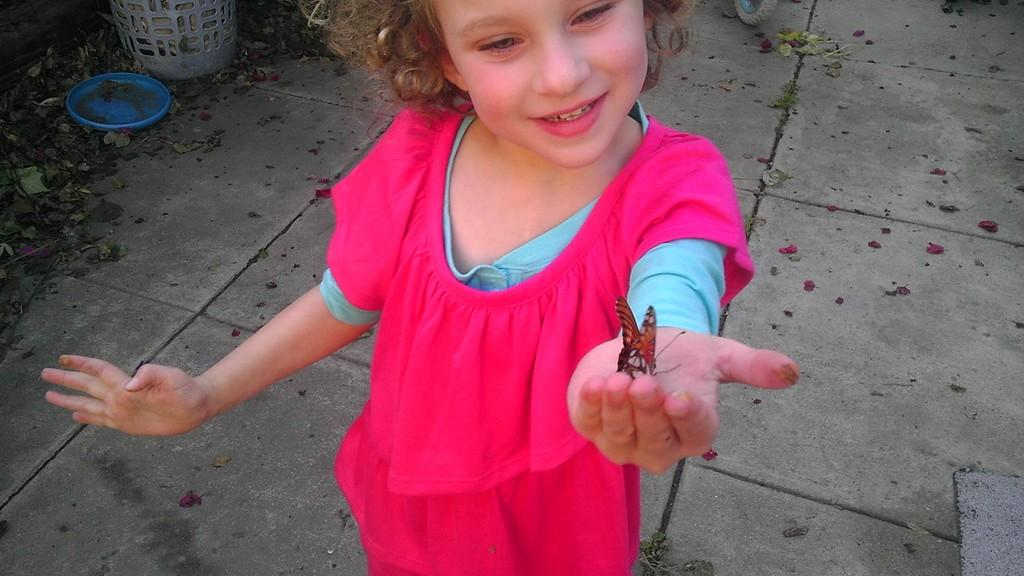What is the main subject of the image? There is a child in the image. What is the child holding in the image? There is a butterfly in the child's hand. What else can be seen on the ground in the image? There are objects on the ground in the image. What level of education does the child have in the image? The image does not provide any information about the child's education. How much blood is visible on the child's hand in the image? There is no blood visible on the child's hand in the image. 